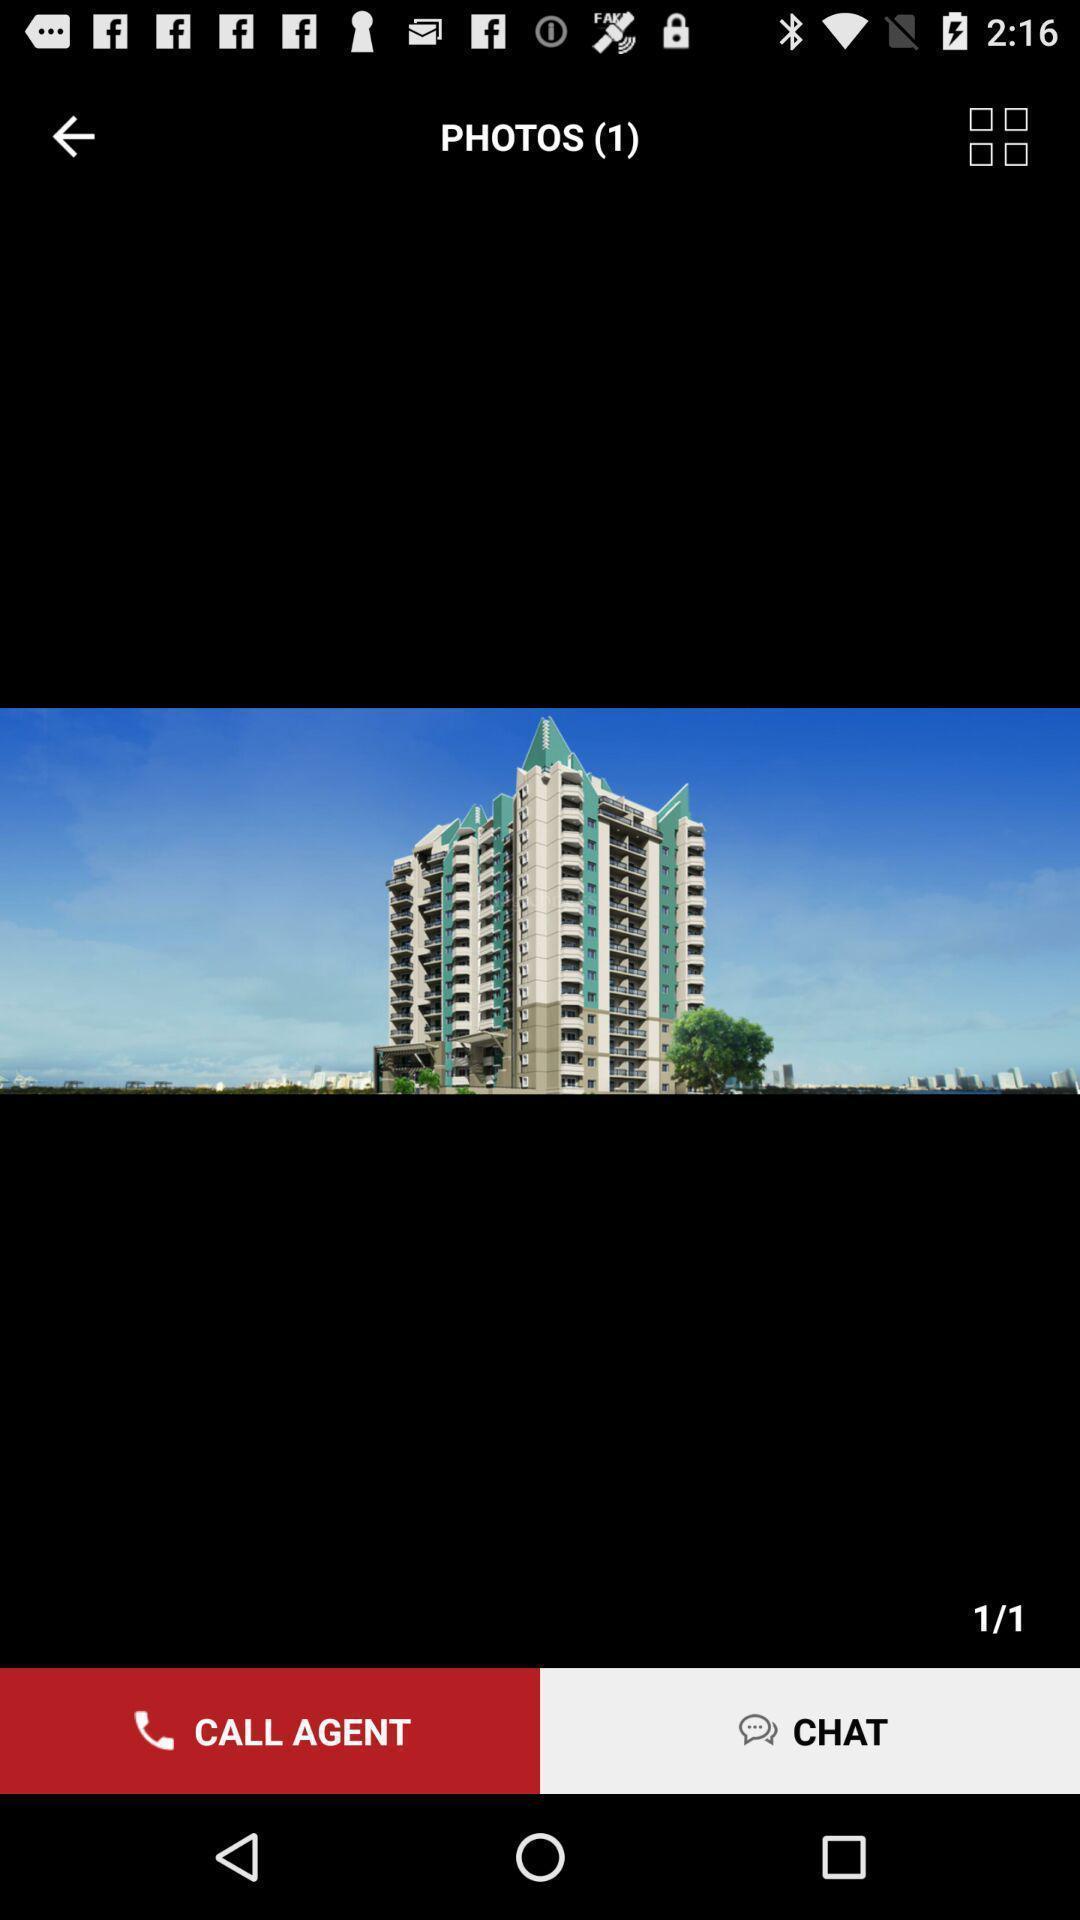Describe the content in this image. Screen displaying the photo of a building. 